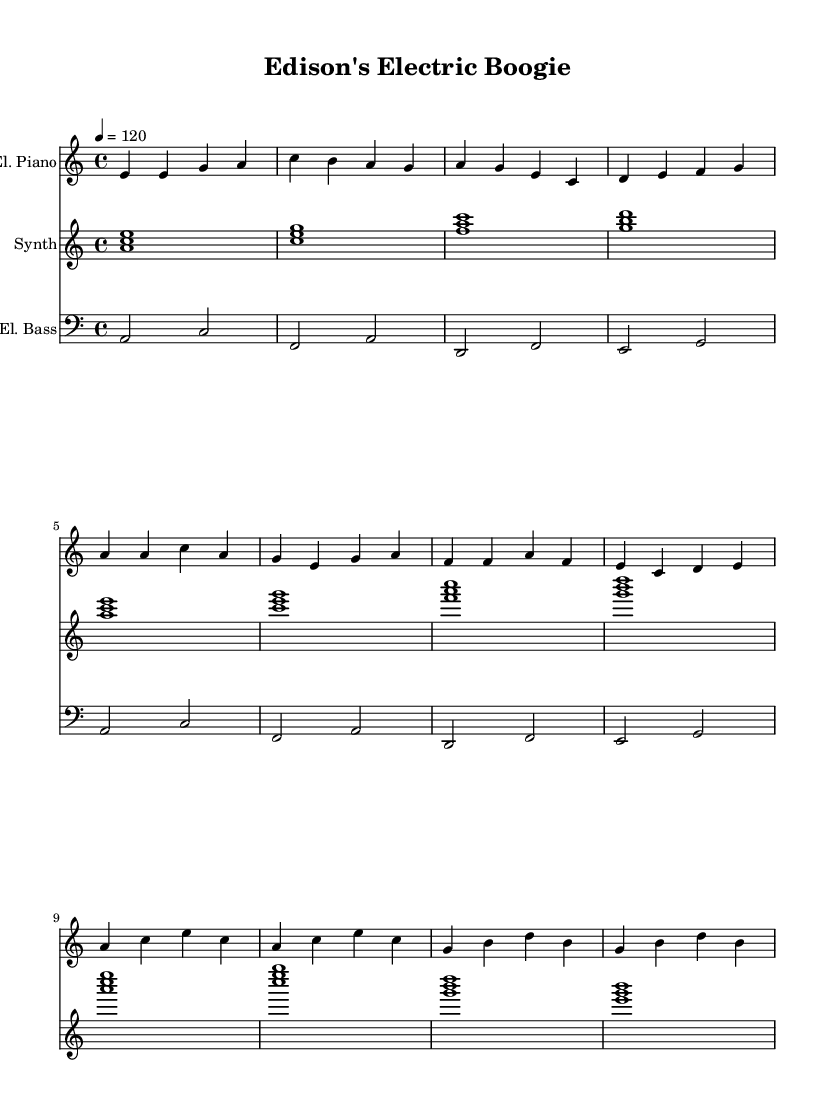What is the key signature of this music? The key signature is indicated by the presence of no sharps or flats in the key signature section at the beginning of the score. This denotes that the piece is in A minor, which corresponds to having no accidentals.
Answer: A minor What is the time signature of this music? The time signature is located at the beginning of the score, represented by the fraction 4/4. This indicates that there are four beats per measure and the quarter note gets one beat.
Answer: 4/4 What is the tempo marked for this piece? The tempo indication can be found at the start of the score, where it states "4 = 120". This means that there should be 120 quarter notes played per minute.
Answer: 120 How many measures are in the verse section? The verse section consists of two lines of music. By counting the measures in each line, we find that there are a total of 4 measures in the verse. Each line contains 4 measures.
Answer: 4 What is the instrument for the first staff? The first staff is labeled "El. Piano," indicating that this staff is designated for the electric piano part of the composition.
Answer: El. Piano Which chord is played in the introduction? The introduction shows the chords in the first line of the synthesizer part, starting with the notes <a c e>, which forms an A minor chord.
Answer: A minor 